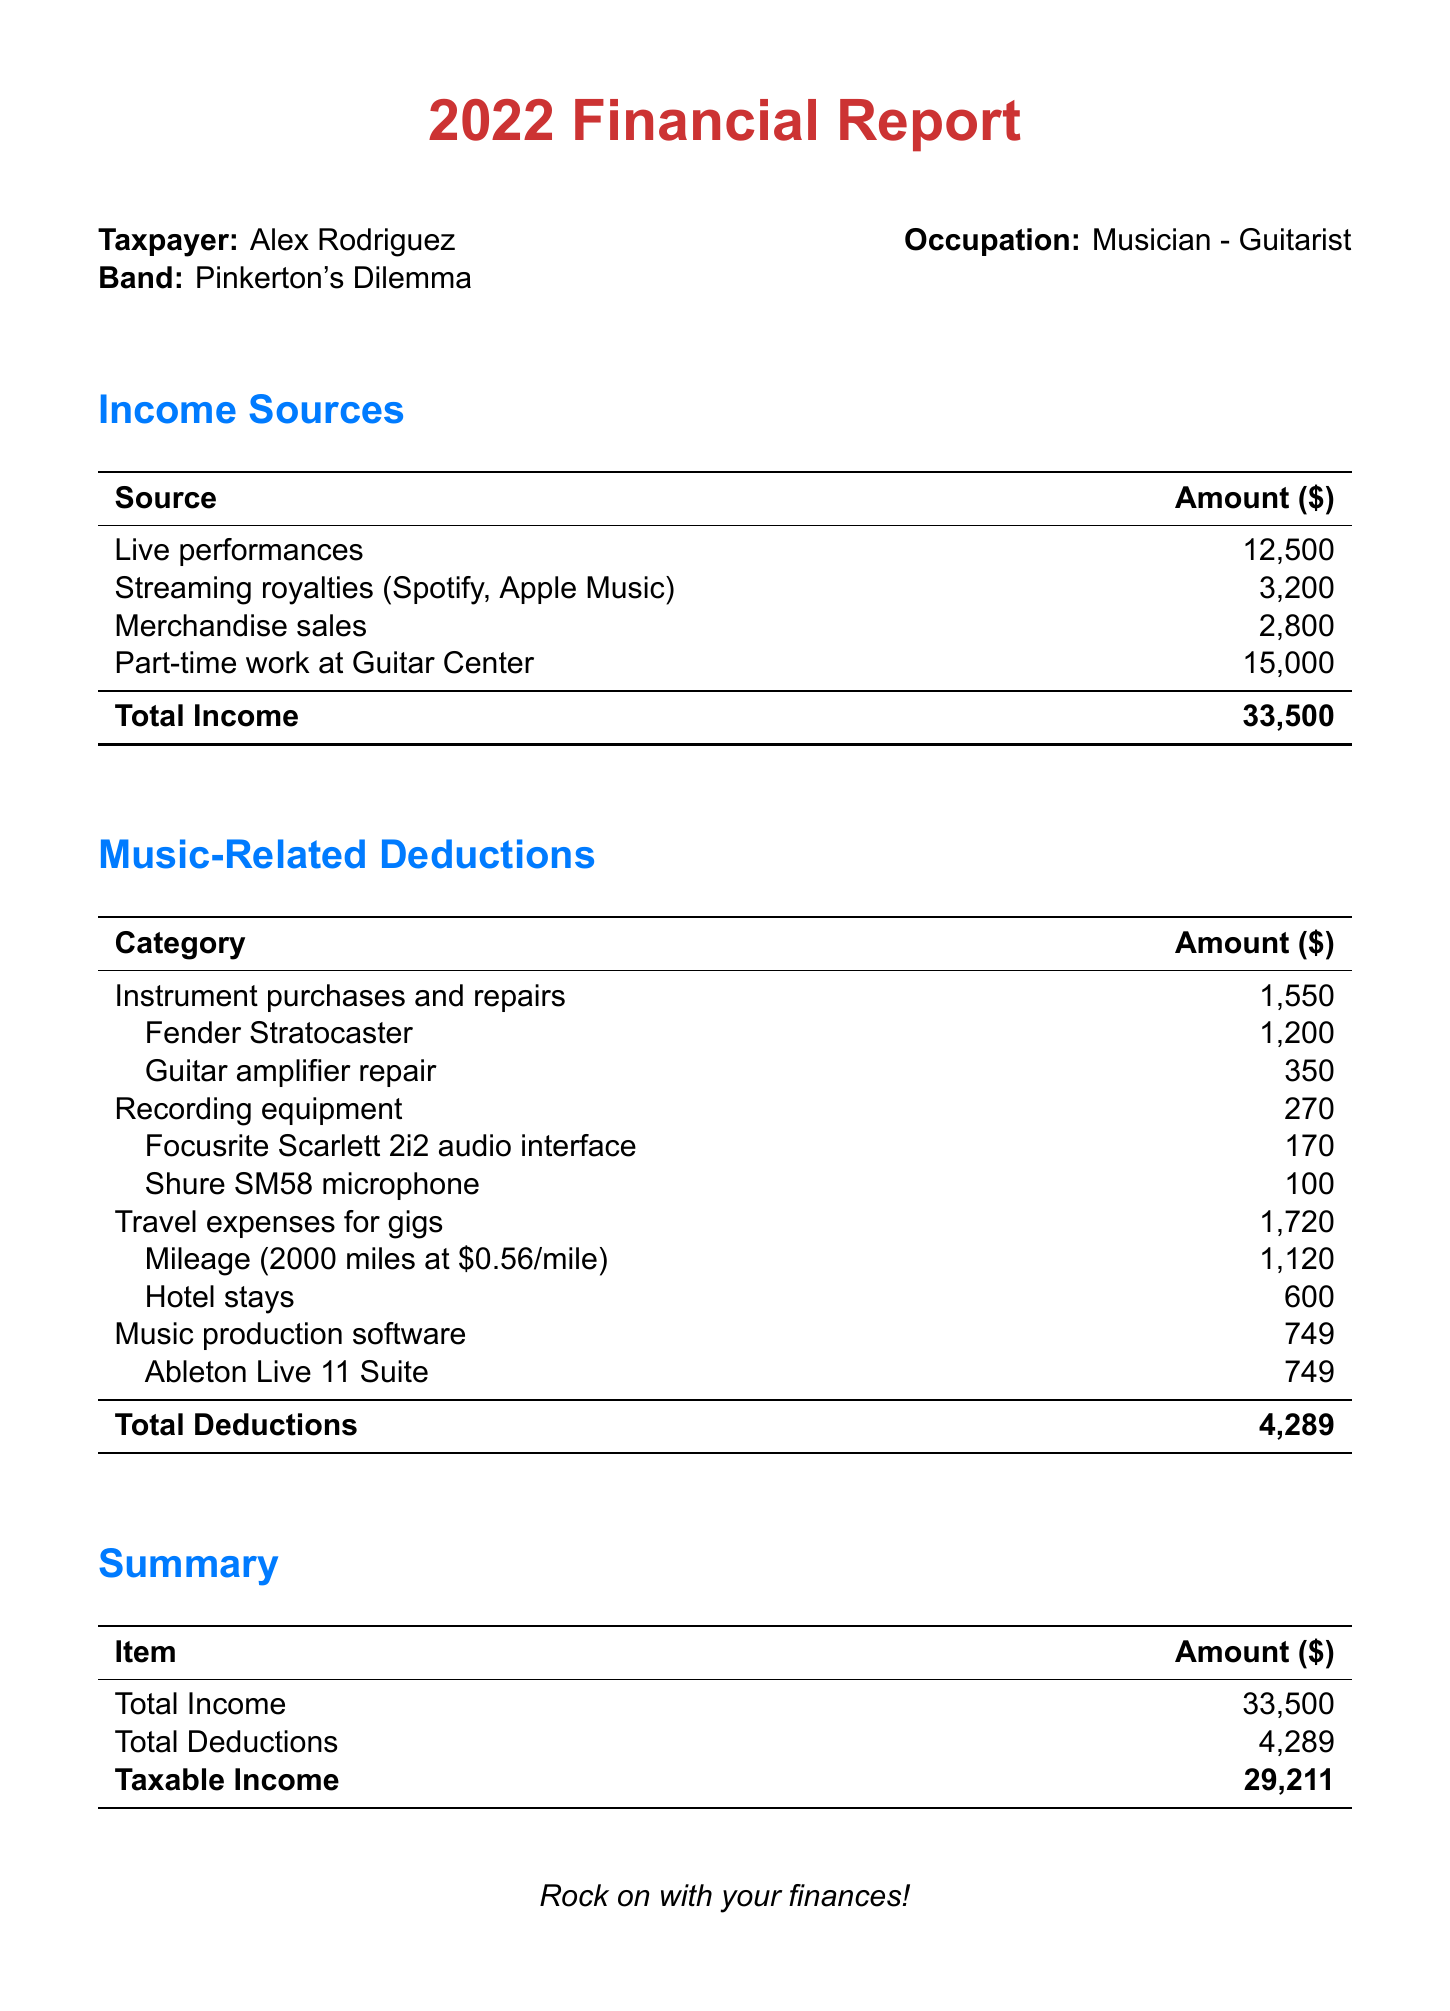What is the name of the taxpayer? The name of the taxpayer is presented in the taxpayer information section of the document.
Answer: Alex Rodriguez What is the total income reported? The total income is given in the summary section as the sum of all income sources.
Answer: 33,500 How much was spent on instrument purchases and repairs? This amount is listed under music-related deductions in the corresponding category.
Answer: 1,550 What was the income from merchandise sales? The document lists the income from merchandise sales as a specific amount in the income sources section.
Answer: 2,800 What is the total amount of deductions? The total deductions are provided at the end of the music-related deductions section.
Answer: 4,289 What was the taxable income for the year? The taxable income is calculated as total income minus total deductions, provided in the summary.
Answer: 29,211 Which band is Alex Rodriguez associated with? The band name is mentioned in the taxpayer information section.
Answer: Pinkerton's Dilemma How much was spent on music production software? This specific expense is detailed under the music-related deductions section.
Answer: 749 What was the income from live performances? The amount earned from live performances is found in the income sources section of the report.
Answer: 12,500 